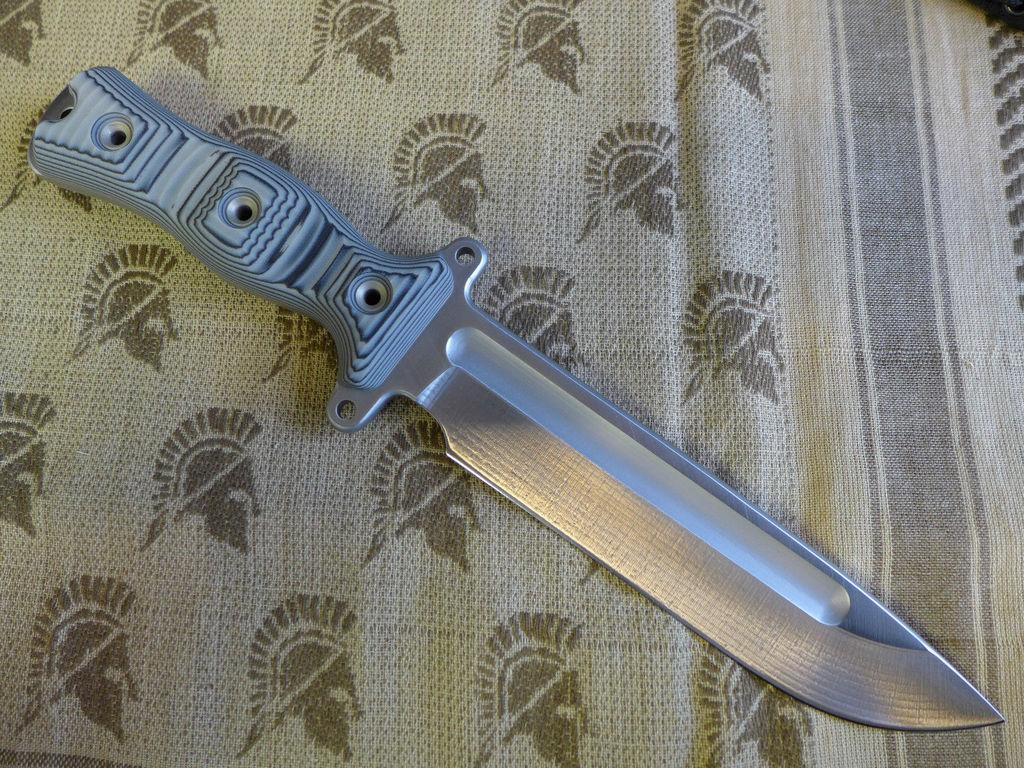What object is located in the center of the image? There is a knife in the center of the image. Can you see the seashore in the background of the image? There is no seashore present in the image; it only features a knife in the center. What type of bit is attached to the knife in the image? There is no bit present in the image, as it only features a knife. Is there an ear visible on the knife in the image? There is no ear present in the image, as it only features a knife. 